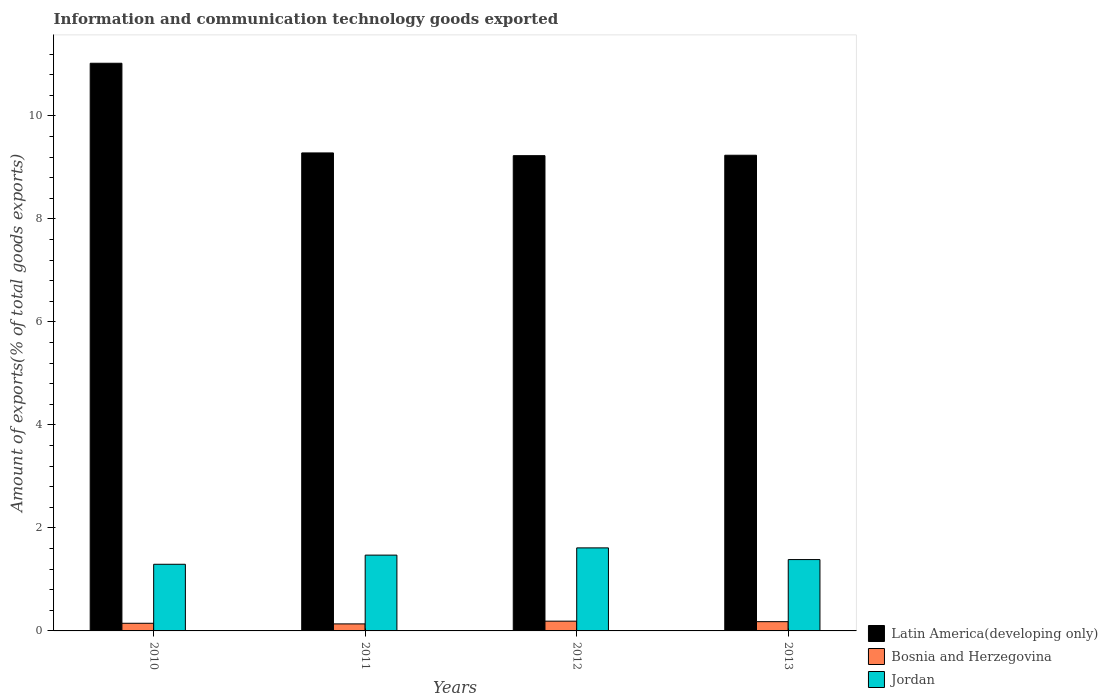Are the number of bars per tick equal to the number of legend labels?
Your answer should be very brief. Yes. What is the label of the 2nd group of bars from the left?
Your answer should be very brief. 2011. What is the amount of goods exported in Latin America(developing only) in 2013?
Your response must be concise. 9.23. Across all years, what is the maximum amount of goods exported in Jordan?
Ensure brevity in your answer.  1.61. Across all years, what is the minimum amount of goods exported in Latin America(developing only)?
Give a very brief answer. 9.23. In which year was the amount of goods exported in Latin America(developing only) minimum?
Make the answer very short. 2012. What is the total amount of goods exported in Bosnia and Herzegovina in the graph?
Ensure brevity in your answer.  0.65. What is the difference between the amount of goods exported in Bosnia and Herzegovina in 2011 and that in 2012?
Provide a succinct answer. -0.05. What is the difference between the amount of goods exported in Latin America(developing only) in 2011 and the amount of goods exported in Bosnia and Herzegovina in 2010?
Your response must be concise. 9.13. What is the average amount of goods exported in Jordan per year?
Your response must be concise. 1.44. In the year 2011, what is the difference between the amount of goods exported in Bosnia and Herzegovina and amount of goods exported in Jordan?
Provide a succinct answer. -1.34. What is the ratio of the amount of goods exported in Latin America(developing only) in 2010 to that in 2013?
Offer a terse response. 1.19. Is the amount of goods exported in Jordan in 2010 less than that in 2013?
Offer a very short reply. Yes. What is the difference between the highest and the second highest amount of goods exported in Latin America(developing only)?
Provide a succinct answer. 1.74. What is the difference between the highest and the lowest amount of goods exported in Jordan?
Offer a terse response. 0.32. What does the 3rd bar from the left in 2013 represents?
Provide a short and direct response. Jordan. What does the 2nd bar from the right in 2012 represents?
Give a very brief answer. Bosnia and Herzegovina. Are all the bars in the graph horizontal?
Your response must be concise. No. How many years are there in the graph?
Offer a very short reply. 4. What is the difference between two consecutive major ticks on the Y-axis?
Provide a short and direct response. 2. Are the values on the major ticks of Y-axis written in scientific E-notation?
Your response must be concise. No. Does the graph contain grids?
Keep it short and to the point. No. How many legend labels are there?
Ensure brevity in your answer.  3. What is the title of the graph?
Offer a very short reply. Information and communication technology goods exported. What is the label or title of the Y-axis?
Ensure brevity in your answer.  Amount of exports(% of total goods exports). What is the Amount of exports(% of total goods exports) of Latin America(developing only) in 2010?
Your response must be concise. 11.02. What is the Amount of exports(% of total goods exports) of Bosnia and Herzegovina in 2010?
Offer a very short reply. 0.15. What is the Amount of exports(% of total goods exports) in Jordan in 2010?
Offer a very short reply. 1.29. What is the Amount of exports(% of total goods exports) in Latin America(developing only) in 2011?
Provide a succinct answer. 9.28. What is the Amount of exports(% of total goods exports) in Bosnia and Herzegovina in 2011?
Give a very brief answer. 0.14. What is the Amount of exports(% of total goods exports) of Jordan in 2011?
Your answer should be very brief. 1.47. What is the Amount of exports(% of total goods exports) of Latin America(developing only) in 2012?
Offer a very short reply. 9.23. What is the Amount of exports(% of total goods exports) of Bosnia and Herzegovina in 2012?
Offer a terse response. 0.19. What is the Amount of exports(% of total goods exports) in Jordan in 2012?
Offer a very short reply. 1.61. What is the Amount of exports(% of total goods exports) in Latin America(developing only) in 2013?
Ensure brevity in your answer.  9.23. What is the Amount of exports(% of total goods exports) of Bosnia and Herzegovina in 2013?
Your answer should be compact. 0.18. What is the Amount of exports(% of total goods exports) of Jordan in 2013?
Make the answer very short. 1.39. Across all years, what is the maximum Amount of exports(% of total goods exports) of Latin America(developing only)?
Make the answer very short. 11.02. Across all years, what is the maximum Amount of exports(% of total goods exports) of Bosnia and Herzegovina?
Your answer should be very brief. 0.19. Across all years, what is the maximum Amount of exports(% of total goods exports) of Jordan?
Your answer should be compact. 1.61. Across all years, what is the minimum Amount of exports(% of total goods exports) of Latin America(developing only)?
Provide a short and direct response. 9.23. Across all years, what is the minimum Amount of exports(% of total goods exports) of Bosnia and Herzegovina?
Keep it short and to the point. 0.14. Across all years, what is the minimum Amount of exports(% of total goods exports) of Jordan?
Your answer should be compact. 1.29. What is the total Amount of exports(% of total goods exports) in Latin America(developing only) in the graph?
Offer a very short reply. 38.76. What is the total Amount of exports(% of total goods exports) in Bosnia and Herzegovina in the graph?
Give a very brief answer. 0.65. What is the total Amount of exports(% of total goods exports) in Jordan in the graph?
Offer a terse response. 5.76. What is the difference between the Amount of exports(% of total goods exports) in Latin America(developing only) in 2010 and that in 2011?
Offer a very short reply. 1.74. What is the difference between the Amount of exports(% of total goods exports) of Bosnia and Herzegovina in 2010 and that in 2011?
Keep it short and to the point. 0.01. What is the difference between the Amount of exports(% of total goods exports) of Jordan in 2010 and that in 2011?
Your response must be concise. -0.18. What is the difference between the Amount of exports(% of total goods exports) of Latin America(developing only) in 2010 and that in 2012?
Provide a short and direct response. 1.79. What is the difference between the Amount of exports(% of total goods exports) in Bosnia and Herzegovina in 2010 and that in 2012?
Your answer should be compact. -0.04. What is the difference between the Amount of exports(% of total goods exports) of Jordan in 2010 and that in 2012?
Make the answer very short. -0.32. What is the difference between the Amount of exports(% of total goods exports) in Latin America(developing only) in 2010 and that in 2013?
Provide a succinct answer. 1.79. What is the difference between the Amount of exports(% of total goods exports) of Bosnia and Herzegovina in 2010 and that in 2013?
Your answer should be very brief. -0.03. What is the difference between the Amount of exports(% of total goods exports) in Jordan in 2010 and that in 2013?
Provide a short and direct response. -0.09. What is the difference between the Amount of exports(% of total goods exports) in Latin America(developing only) in 2011 and that in 2012?
Your answer should be very brief. 0.05. What is the difference between the Amount of exports(% of total goods exports) in Bosnia and Herzegovina in 2011 and that in 2012?
Ensure brevity in your answer.  -0.05. What is the difference between the Amount of exports(% of total goods exports) of Jordan in 2011 and that in 2012?
Your response must be concise. -0.14. What is the difference between the Amount of exports(% of total goods exports) of Latin America(developing only) in 2011 and that in 2013?
Your answer should be very brief. 0.04. What is the difference between the Amount of exports(% of total goods exports) in Bosnia and Herzegovina in 2011 and that in 2013?
Make the answer very short. -0.04. What is the difference between the Amount of exports(% of total goods exports) of Jordan in 2011 and that in 2013?
Your answer should be very brief. 0.09. What is the difference between the Amount of exports(% of total goods exports) of Latin America(developing only) in 2012 and that in 2013?
Offer a terse response. -0.01. What is the difference between the Amount of exports(% of total goods exports) in Bosnia and Herzegovina in 2012 and that in 2013?
Offer a very short reply. 0.01. What is the difference between the Amount of exports(% of total goods exports) in Jordan in 2012 and that in 2013?
Make the answer very short. 0.23. What is the difference between the Amount of exports(% of total goods exports) in Latin America(developing only) in 2010 and the Amount of exports(% of total goods exports) in Bosnia and Herzegovina in 2011?
Provide a succinct answer. 10.88. What is the difference between the Amount of exports(% of total goods exports) in Latin America(developing only) in 2010 and the Amount of exports(% of total goods exports) in Jordan in 2011?
Make the answer very short. 9.55. What is the difference between the Amount of exports(% of total goods exports) in Bosnia and Herzegovina in 2010 and the Amount of exports(% of total goods exports) in Jordan in 2011?
Give a very brief answer. -1.32. What is the difference between the Amount of exports(% of total goods exports) of Latin America(developing only) in 2010 and the Amount of exports(% of total goods exports) of Bosnia and Herzegovina in 2012?
Offer a very short reply. 10.83. What is the difference between the Amount of exports(% of total goods exports) of Latin America(developing only) in 2010 and the Amount of exports(% of total goods exports) of Jordan in 2012?
Give a very brief answer. 9.41. What is the difference between the Amount of exports(% of total goods exports) in Bosnia and Herzegovina in 2010 and the Amount of exports(% of total goods exports) in Jordan in 2012?
Make the answer very short. -1.46. What is the difference between the Amount of exports(% of total goods exports) of Latin America(developing only) in 2010 and the Amount of exports(% of total goods exports) of Bosnia and Herzegovina in 2013?
Offer a terse response. 10.84. What is the difference between the Amount of exports(% of total goods exports) of Latin America(developing only) in 2010 and the Amount of exports(% of total goods exports) of Jordan in 2013?
Make the answer very short. 9.64. What is the difference between the Amount of exports(% of total goods exports) of Bosnia and Herzegovina in 2010 and the Amount of exports(% of total goods exports) of Jordan in 2013?
Keep it short and to the point. -1.24. What is the difference between the Amount of exports(% of total goods exports) in Latin America(developing only) in 2011 and the Amount of exports(% of total goods exports) in Bosnia and Herzegovina in 2012?
Provide a short and direct response. 9.09. What is the difference between the Amount of exports(% of total goods exports) in Latin America(developing only) in 2011 and the Amount of exports(% of total goods exports) in Jordan in 2012?
Provide a succinct answer. 7.67. What is the difference between the Amount of exports(% of total goods exports) of Bosnia and Herzegovina in 2011 and the Amount of exports(% of total goods exports) of Jordan in 2012?
Give a very brief answer. -1.48. What is the difference between the Amount of exports(% of total goods exports) in Latin America(developing only) in 2011 and the Amount of exports(% of total goods exports) in Bosnia and Herzegovina in 2013?
Your answer should be very brief. 9.1. What is the difference between the Amount of exports(% of total goods exports) of Latin America(developing only) in 2011 and the Amount of exports(% of total goods exports) of Jordan in 2013?
Ensure brevity in your answer.  7.89. What is the difference between the Amount of exports(% of total goods exports) of Bosnia and Herzegovina in 2011 and the Amount of exports(% of total goods exports) of Jordan in 2013?
Make the answer very short. -1.25. What is the difference between the Amount of exports(% of total goods exports) in Latin America(developing only) in 2012 and the Amount of exports(% of total goods exports) in Bosnia and Herzegovina in 2013?
Provide a succinct answer. 9.05. What is the difference between the Amount of exports(% of total goods exports) in Latin America(developing only) in 2012 and the Amount of exports(% of total goods exports) in Jordan in 2013?
Make the answer very short. 7.84. What is the difference between the Amount of exports(% of total goods exports) of Bosnia and Herzegovina in 2012 and the Amount of exports(% of total goods exports) of Jordan in 2013?
Your answer should be very brief. -1.2. What is the average Amount of exports(% of total goods exports) of Latin America(developing only) per year?
Offer a terse response. 9.69. What is the average Amount of exports(% of total goods exports) in Bosnia and Herzegovina per year?
Make the answer very short. 0.16. What is the average Amount of exports(% of total goods exports) in Jordan per year?
Make the answer very short. 1.44. In the year 2010, what is the difference between the Amount of exports(% of total goods exports) of Latin America(developing only) and Amount of exports(% of total goods exports) of Bosnia and Herzegovina?
Provide a succinct answer. 10.87. In the year 2010, what is the difference between the Amount of exports(% of total goods exports) in Latin America(developing only) and Amount of exports(% of total goods exports) in Jordan?
Keep it short and to the point. 9.73. In the year 2010, what is the difference between the Amount of exports(% of total goods exports) of Bosnia and Herzegovina and Amount of exports(% of total goods exports) of Jordan?
Give a very brief answer. -1.15. In the year 2011, what is the difference between the Amount of exports(% of total goods exports) of Latin America(developing only) and Amount of exports(% of total goods exports) of Bosnia and Herzegovina?
Provide a short and direct response. 9.14. In the year 2011, what is the difference between the Amount of exports(% of total goods exports) in Latin America(developing only) and Amount of exports(% of total goods exports) in Jordan?
Make the answer very short. 7.81. In the year 2011, what is the difference between the Amount of exports(% of total goods exports) in Bosnia and Herzegovina and Amount of exports(% of total goods exports) in Jordan?
Provide a short and direct response. -1.34. In the year 2012, what is the difference between the Amount of exports(% of total goods exports) in Latin America(developing only) and Amount of exports(% of total goods exports) in Bosnia and Herzegovina?
Keep it short and to the point. 9.04. In the year 2012, what is the difference between the Amount of exports(% of total goods exports) in Latin America(developing only) and Amount of exports(% of total goods exports) in Jordan?
Make the answer very short. 7.61. In the year 2012, what is the difference between the Amount of exports(% of total goods exports) in Bosnia and Herzegovina and Amount of exports(% of total goods exports) in Jordan?
Your response must be concise. -1.42. In the year 2013, what is the difference between the Amount of exports(% of total goods exports) in Latin America(developing only) and Amount of exports(% of total goods exports) in Bosnia and Herzegovina?
Provide a short and direct response. 9.05. In the year 2013, what is the difference between the Amount of exports(% of total goods exports) of Latin America(developing only) and Amount of exports(% of total goods exports) of Jordan?
Your answer should be very brief. 7.85. In the year 2013, what is the difference between the Amount of exports(% of total goods exports) in Bosnia and Herzegovina and Amount of exports(% of total goods exports) in Jordan?
Your response must be concise. -1.21. What is the ratio of the Amount of exports(% of total goods exports) of Latin America(developing only) in 2010 to that in 2011?
Offer a terse response. 1.19. What is the ratio of the Amount of exports(% of total goods exports) in Bosnia and Herzegovina in 2010 to that in 2011?
Your response must be concise. 1.09. What is the ratio of the Amount of exports(% of total goods exports) in Jordan in 2010 to that in 2011?
Make the answer very short. 0.88. What is the ratio of the Amount of exports(% of total goods exports) of Latin America(developing only) in 2010 to that in 2012?
Provide a succinct answer. 1.19. What is the ratio of the Amount of exports(% of total goods exports) in Bosnia and Herzegovina in 2010 to that in 2012?
Offer a terse response. 0.78. What is the ratio of the Amount of exports(% of total goods exports) in Jordan in 2010 to that in 2012?
Your response must be concise. 0.8. What is the ratio of the Amount of exports(% of total goods exports) in Latin America(developing only) in 2010 to that in 2013?
Your answer should be compact. 1.19. What is the ratio of the Amount of exports(% of total goods exports) in Bosnia and Herzegovina in 2010 to that in 2013?
Ensure brevity in your answer.  0.83. What is the ratio of the Amount of exports(% of total goods exports) of Jordan in 2010 to that in 2013?
Provide a short and direct response. 0.93. What is the ratio of the Amount of exports(% of total goods exports) of Latin America(developing only) in 2011 to that in 2012?
Keep it short and to the point. 1.01. What is the ratio of the Amount of exports(% of total goods exports) in Bosnia and Herzegovina in 2011 to that in 2012?
Provide a succinct answer. 0.72. What is the ratio of the Amount of exports(% of total goods exports) of Jordan in 2011 to that in 2012?
Your answer should be very brief. 0.91. What is the ratio of the Amount of exports(% of total goods exports) in Latin America(developing only) in 2011 to that in 2013?
Offer a terse response. 1. What is the ratio of the Amount of exports(% of total goods exports) in Bosnia and Herzegovina in 2011 to that in 2013?
Ensure brevity in your answer.  0.76. What is the ratio of the Amount of exports(% of total goods exports) of Jordan in 2011 to that in 2013?
Your answer should be very brief. 1.06. What is the ratio of the Amount of exports(% of total goods exports) in Latin America(developing only) in 2012 to that in 2013?
Your answer should be compact. 1. What is the ratio of the Amount of exports(% of total goods exports) of Bosnia and Herzegovina in 2012 to that in 2013?
Your answer should be compact. 1.05. What is the ratio of the Amount of exports(% of total goods exports) in Jordan in 2012 to that in 2013?
Offer a terse response. 1.16. What is the difference between the highest and the second highest Amount of exports(% of total goods exports) of Latin America(developing only)?
Offer a very short reply. 1.74. What is the difference between the highest and the second highest Amount of exports(% of total goods exports) of Bosnia and Herzegovina?
Make the answer very short. 0.01. What is the difference between the highest and the second highest Amount of exports(% of total goods exports) of Jordan?
Keep it short and to the point. 0.14. What is the difference between the highest and the lowest Amount of exports(% of total goods exports) of Latin America(developing only)?
Keep it short and to the point. 1.79. What is the difference between the highest and the lowest Amount of exports(% of total goods exports) of Bosnia and Herzegovina?
Make the answer very short. 0.05. What is the difference between the highest and the lowest Amount of exports(% of total goods exports) in Jordan?
Give a very brief answer. 0.32. 